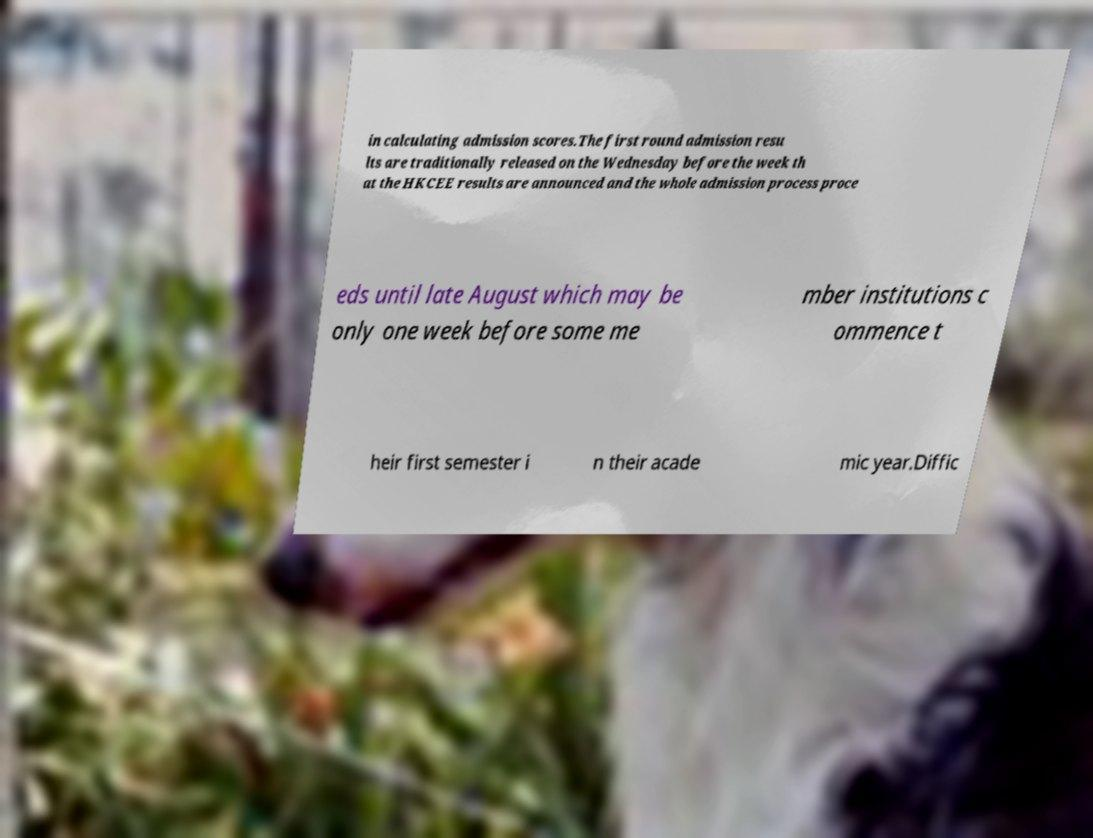Could you extract and type out the text from this image? in calculating admission scores.The first round admission resu lts are traditionally released on the Wednesday before the week th at the HKCEE results are announced and the whole admission process proce eds until late August which may be only one week before some me mber institutions c ommence t heir first semester i n their acade mic year.Diffic 